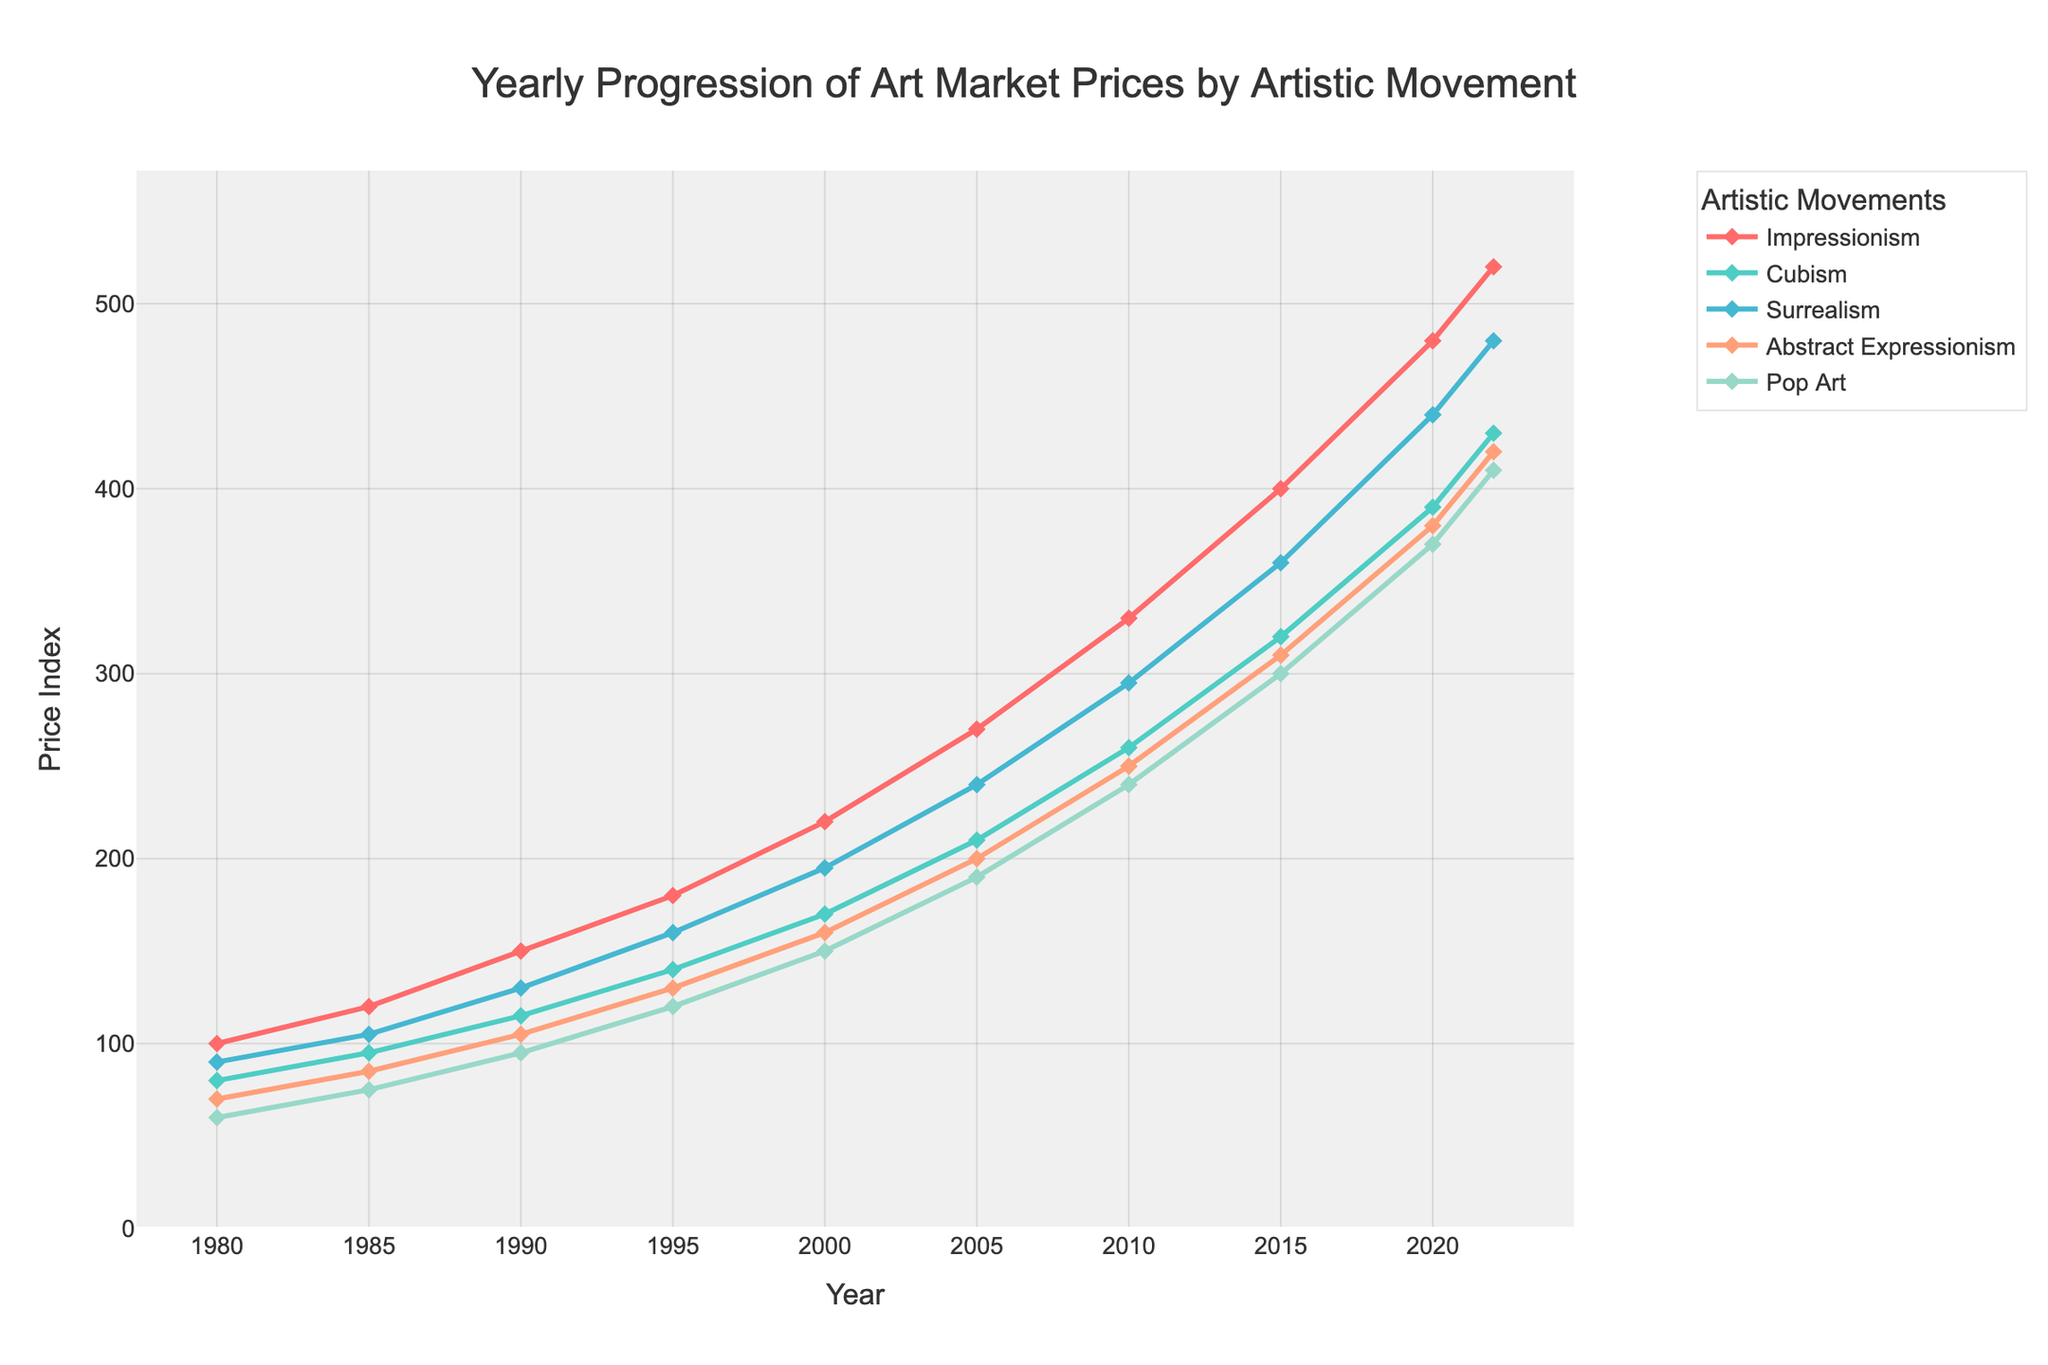Which artistic movement shows the highest price index in the year 2022? In 2022, Impressionism has the highest price index as shown by the highest point on the chart with 520.
Answer: Impressionism What is the price difference between Cubism and Surrealism in 2010? The price index for Cubism in 2010 is 260 and for Surrealism, it is 295. The difference is 295 - 260 = 35.
Answer: 35 Which artistic movement saw the greatest increase in price index from 1980 to 2022? Impressionism increased from 100 in 1980 to 520 in 2022, which is an increase of 420, the highest among all movements.
Answer: Impressionism Between 1990 and 2000, which artistic movement had the smallest increase in price index, and by how much? In 1990, Impressionism is 150, Cubism is 115, Surrealism is 130, Abstract Expressionism is 105, Pop Art is 95. In 2000, Impressionism is 220, Cubism is 170, Surrealism is 195, Abstract Expressionism is 160, Pop Art is 150. For each movement, the increase is Impressionism: 220-150=70, Cubism: 170-115=55, Surrealism: 195-130=65, Abstract Expressionism: 160-105=55, and Pop Art: 150-95=55. The smallest increase is shared by Cubism, Abstract Expressionism, and Pop Art, each with an increase of 55.
Answer: Cubism, Abstract Expressionism, Pop Art; 55 How does the relative ranking of the price index for Pop Art compare in 1980 and 2022? In 1980, Pop Art has the lowest price index with a value of 60, making it the 5th. In 2022, Pop Art has a value of 410, making it the 5th again, indicating Pop Art remains at the same relative ranking over these years.
Answer: 5th in both years What is the average price index for Surrealism over the entire period shown? The Surrealism price index for the years 1980, 1985, 1990, 1995, 2000, 2005, 2010, 2015, 2020, and 2022 are 90, 105, 130, 160, 195, 240, 295, 360, 440, 480 respectively. The sum is 90+105+130+160+195+240+295+360+440+480 = 2495. The average is 2495/10 = 249.5.
Answer: 249.5 In what year did Abstract Expressionism price index cross 100? Checking the values for Abstract Expressionism, the price index crosses 100 between 1985 (85) and 1990 (105). Thus, the year is 1990.
Answer: 1990 Which artistic movement has the most constant rate of growth in price index from 1980 to 2022? By observing the chart, the lines get steeper at different points. Impressionism and Cubism lines increase fairly steadily, but the rate for Cubism appears more uniform.
Answer: Cubism What is the combined price index for all artistic movements in 1985? The price index for each movement in 1985: Impressionism is 120, Cubism is 95, Surrealism is 105, Abstract Expressionism is 85, and Pop Art is 75. Combined, it is 120+95+105+85+75 = 480.
Answer: 480 